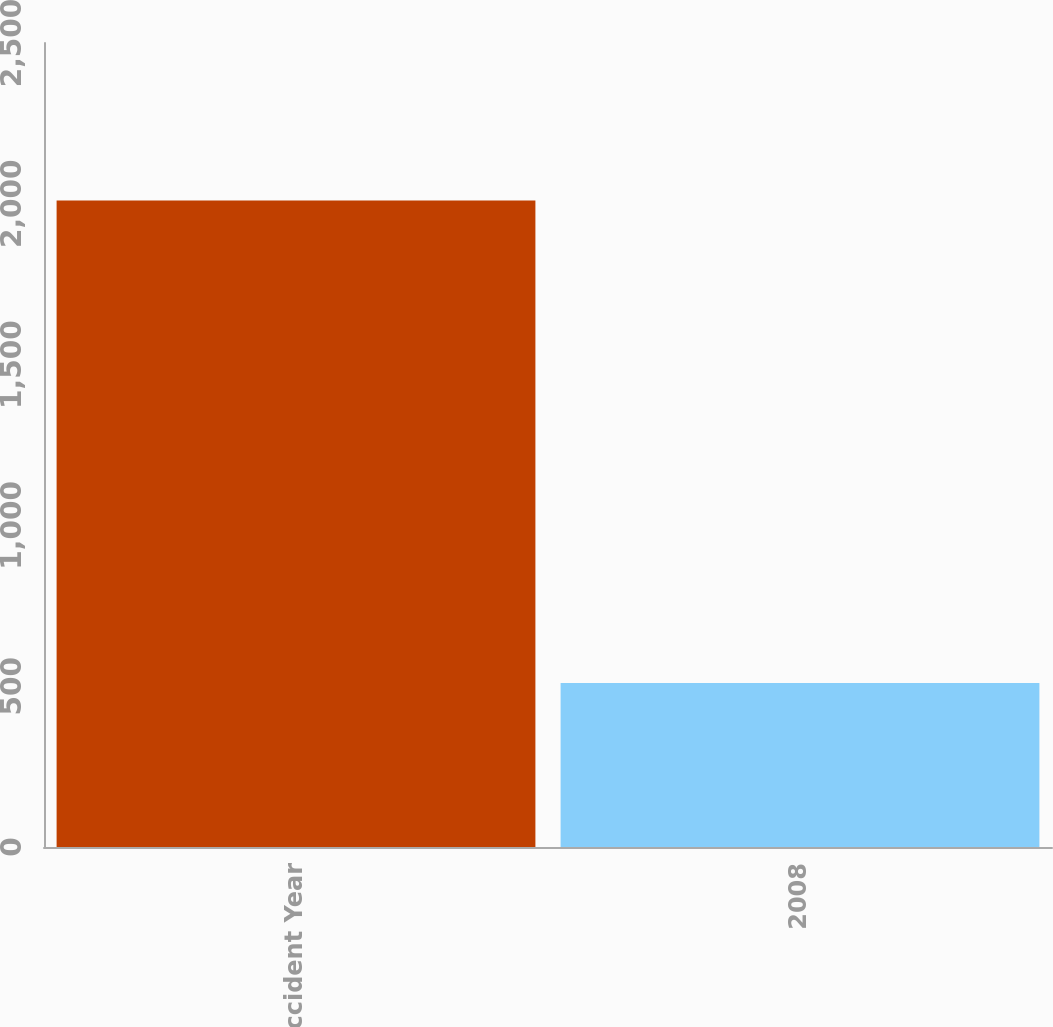Convert chart to OTSL. <chart><loc_0><loc_0><loc_500><loc_500><bar_chart><fcel>Accident Year<fcel>2008<nl><fcel>2010<fcel>510<nl></chart> 